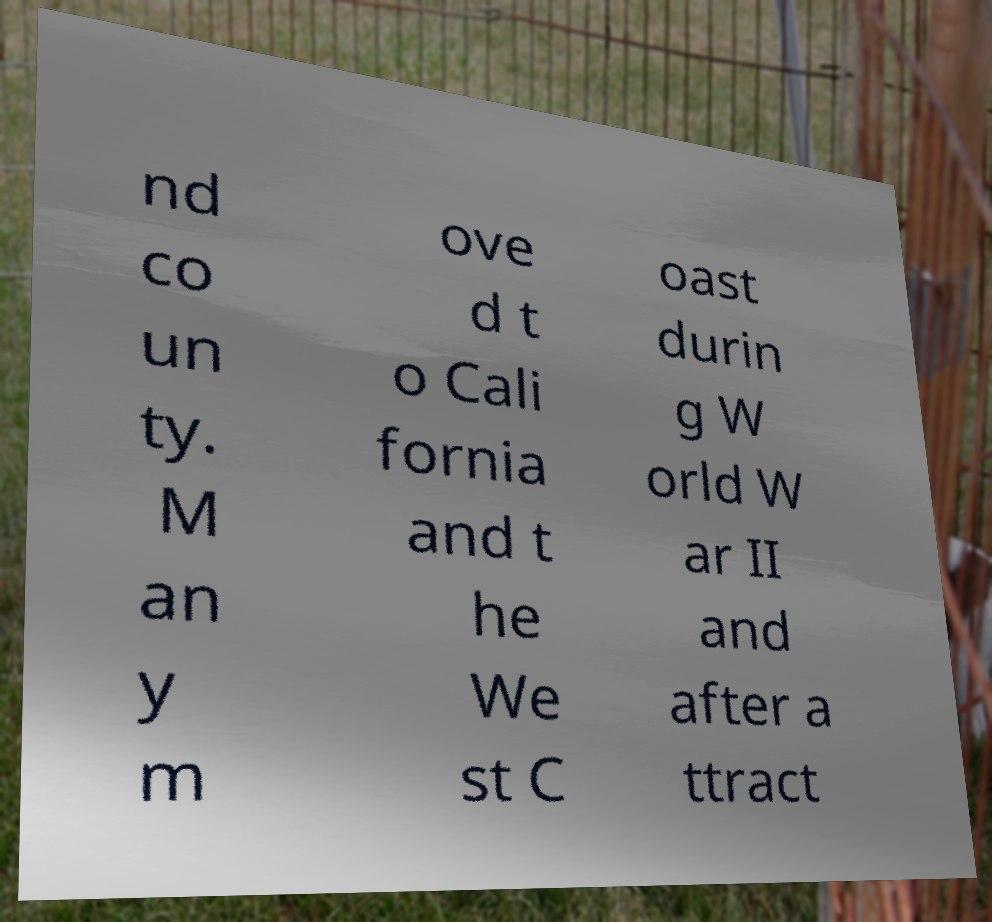Can you read and provide the text displayed in the image?This photo seems to have some interesting text. Can you extract and type it out for me? nd co un ty. M an y m ove d t o Cali fornia and t he We st C oast durin g W orld W ar II and after a ttract 